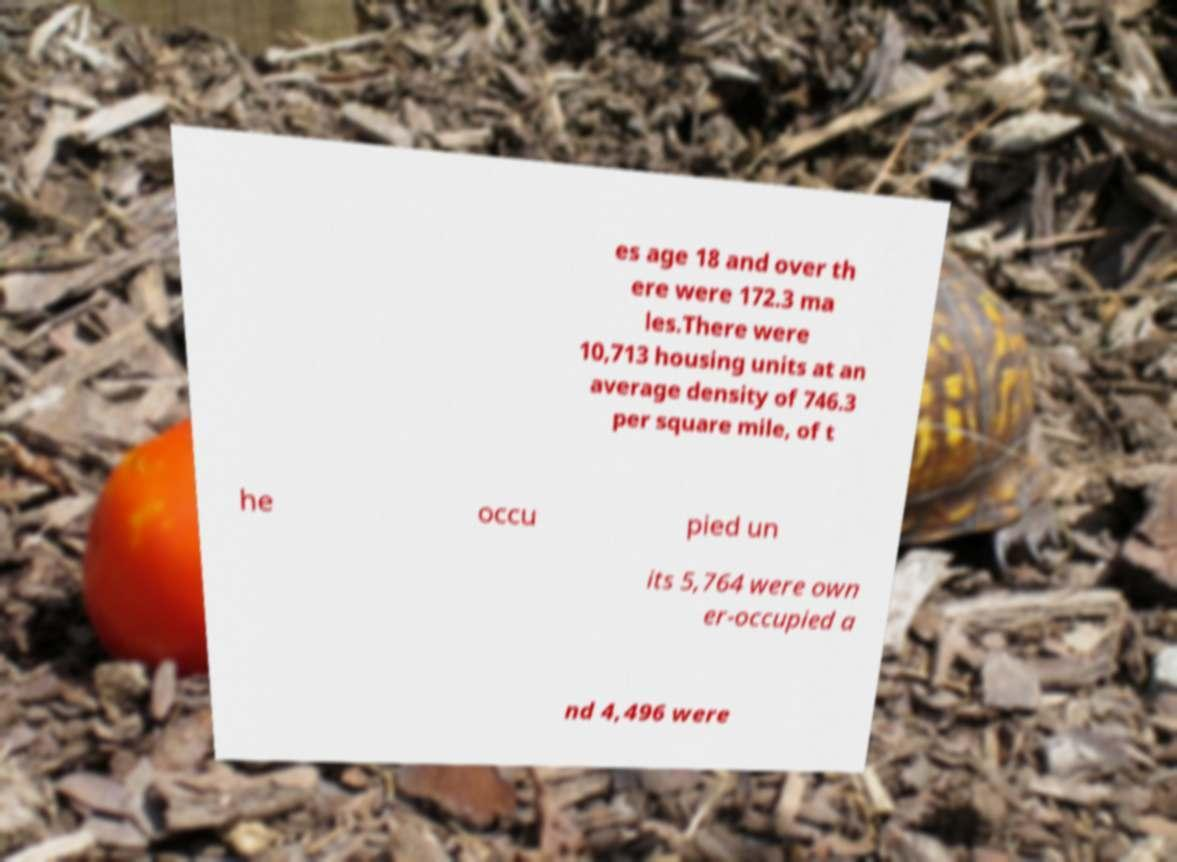I need the written content from this picture converted into text. Can you do that? es age 18 and over th ere were 172.3 ma les.There were 10,713 housing units at an average density of 746.3 per square mile, of t he occu pied un its 5,764 were own er-occupied a nd 4,496 were 